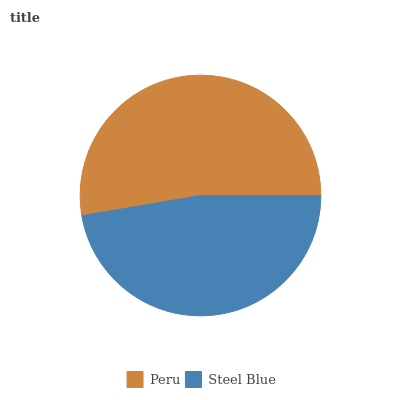Is Steel Blue the minimum?
Answer yes or no. Yes. Is Peru the maximum?
Answer yes or no. Yes. Is Steel Blue the maximum?
Answer yes or no. No. Is Peru greater than Steel Blue?
Answer yes or no. Yes. Is Steel Blue less than Peru?
Answer yes or no. Yes. Is Steel Blue greater than Peru?
Answer yes or no. No. Is Peru less than Steel Blue?
Answer yes or no. No. Is Peru the high median?
Answer yes or no. Yes. Is Steel Blue the low median?
Answer yes or no. Yes. Is Steel Blue the high median?
Answer yes or no. No. Is Peru the low median?
Answer yes or no. No. 